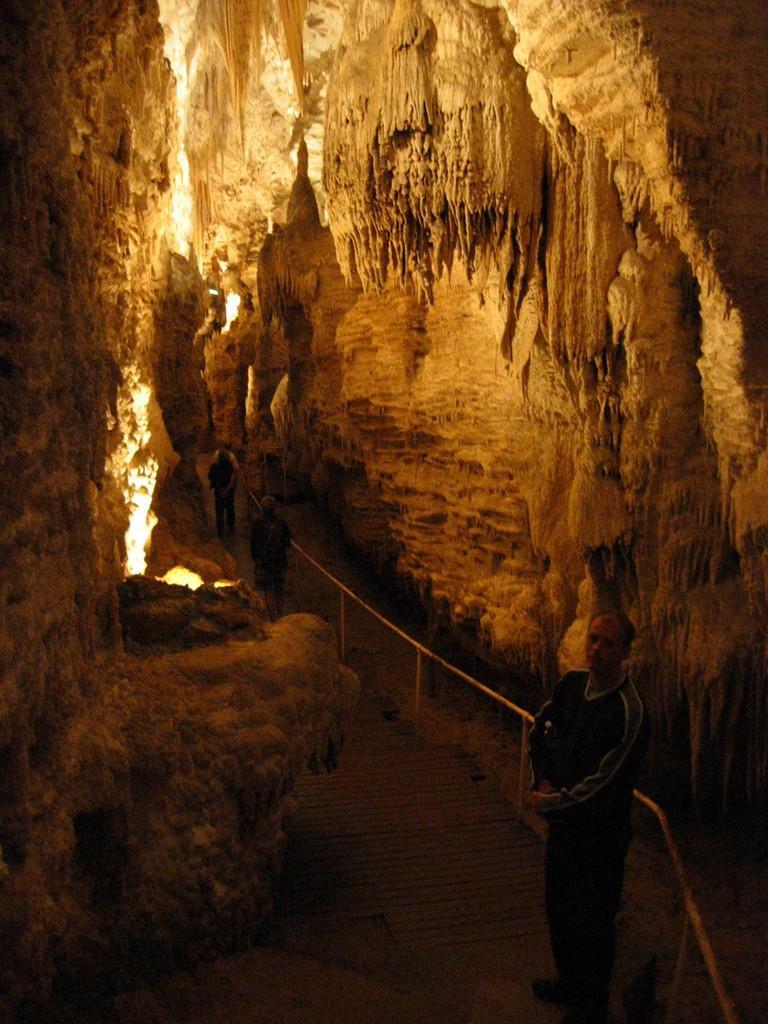Describe this image in one or two sentences. Inside a cave there is a path to walk through it and few people are walking on that path. 